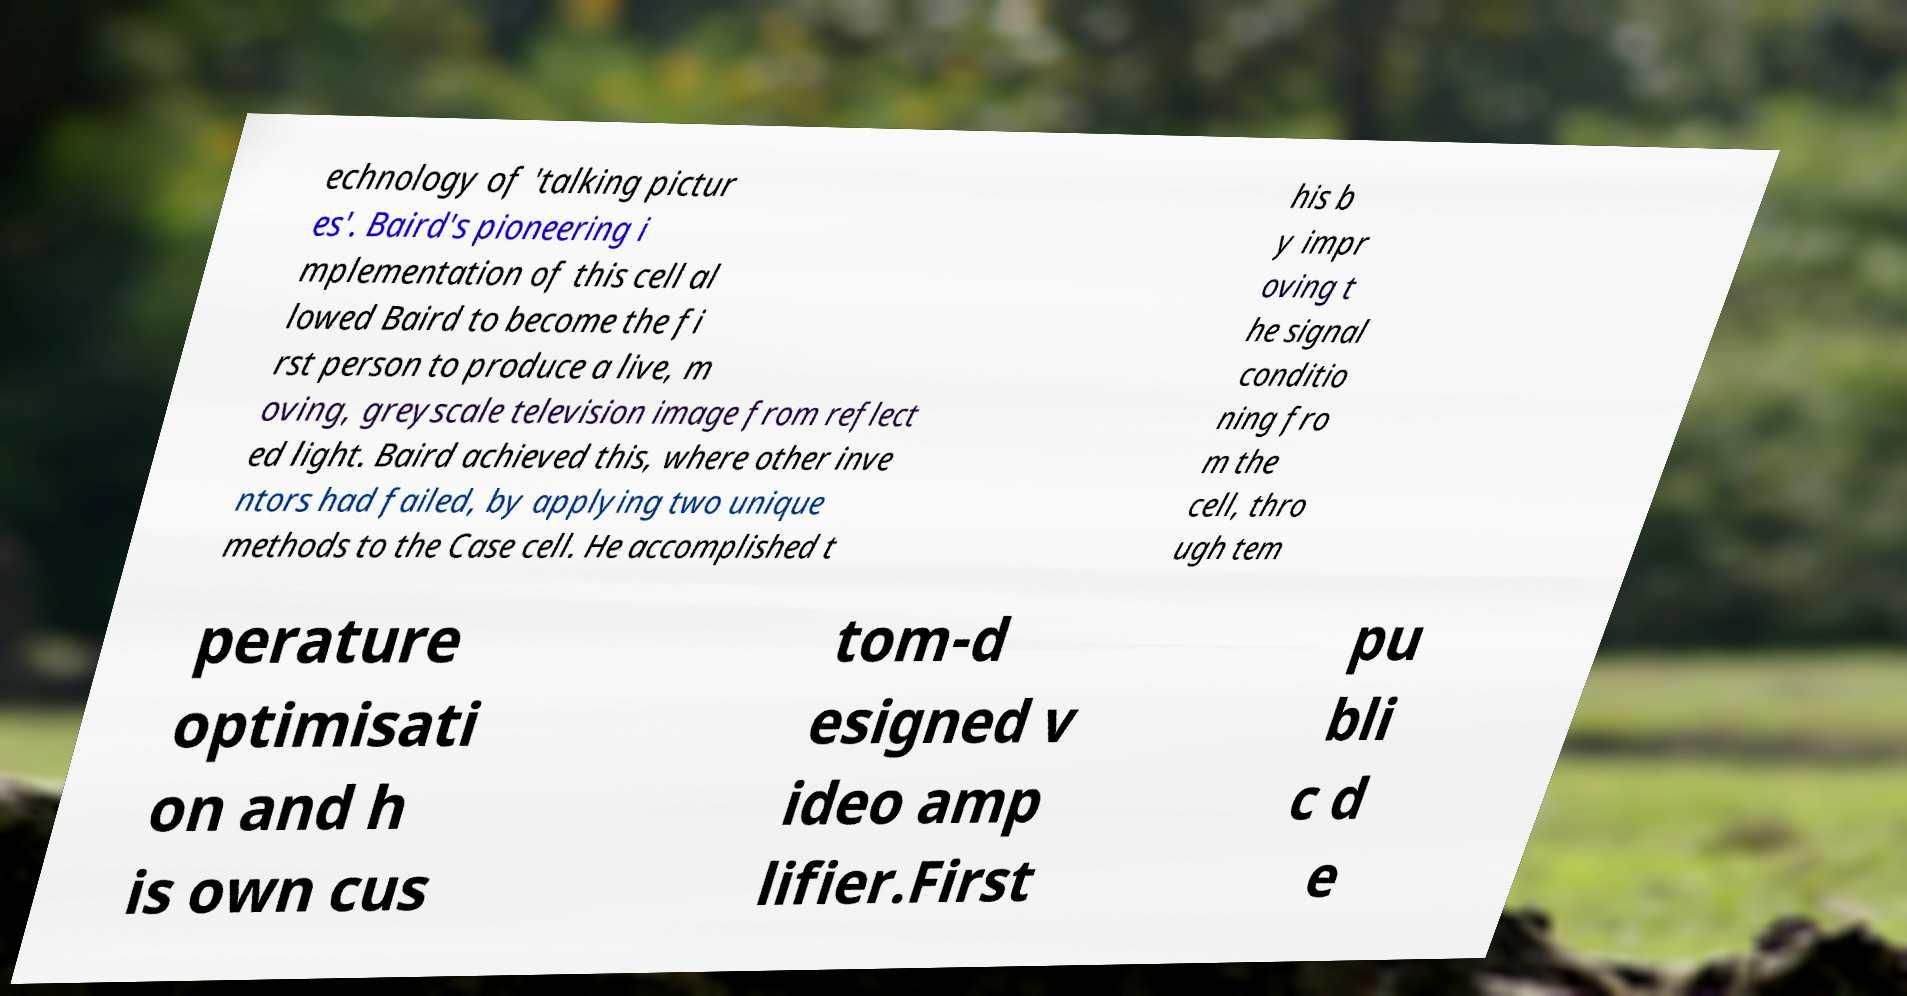Can you accurately transcribe the text from the provided image for me? echnology of 'talking pictur es'. Baird's pioneering i mplementation of this cell al lowed Baird to become the fi rst person to produce a live, m oving, greyscale television image from reflect ed light. Baird achieved this, where other inve ntors had failed, by applying two unique methods to the Case cell. He accomplished t his b y impr oving t he signal conditio ning fro m the cell, thro ugh tem perature optimisati on and h is own cus tom-d esigned v ideo amp lifier.First pu bli c d e 